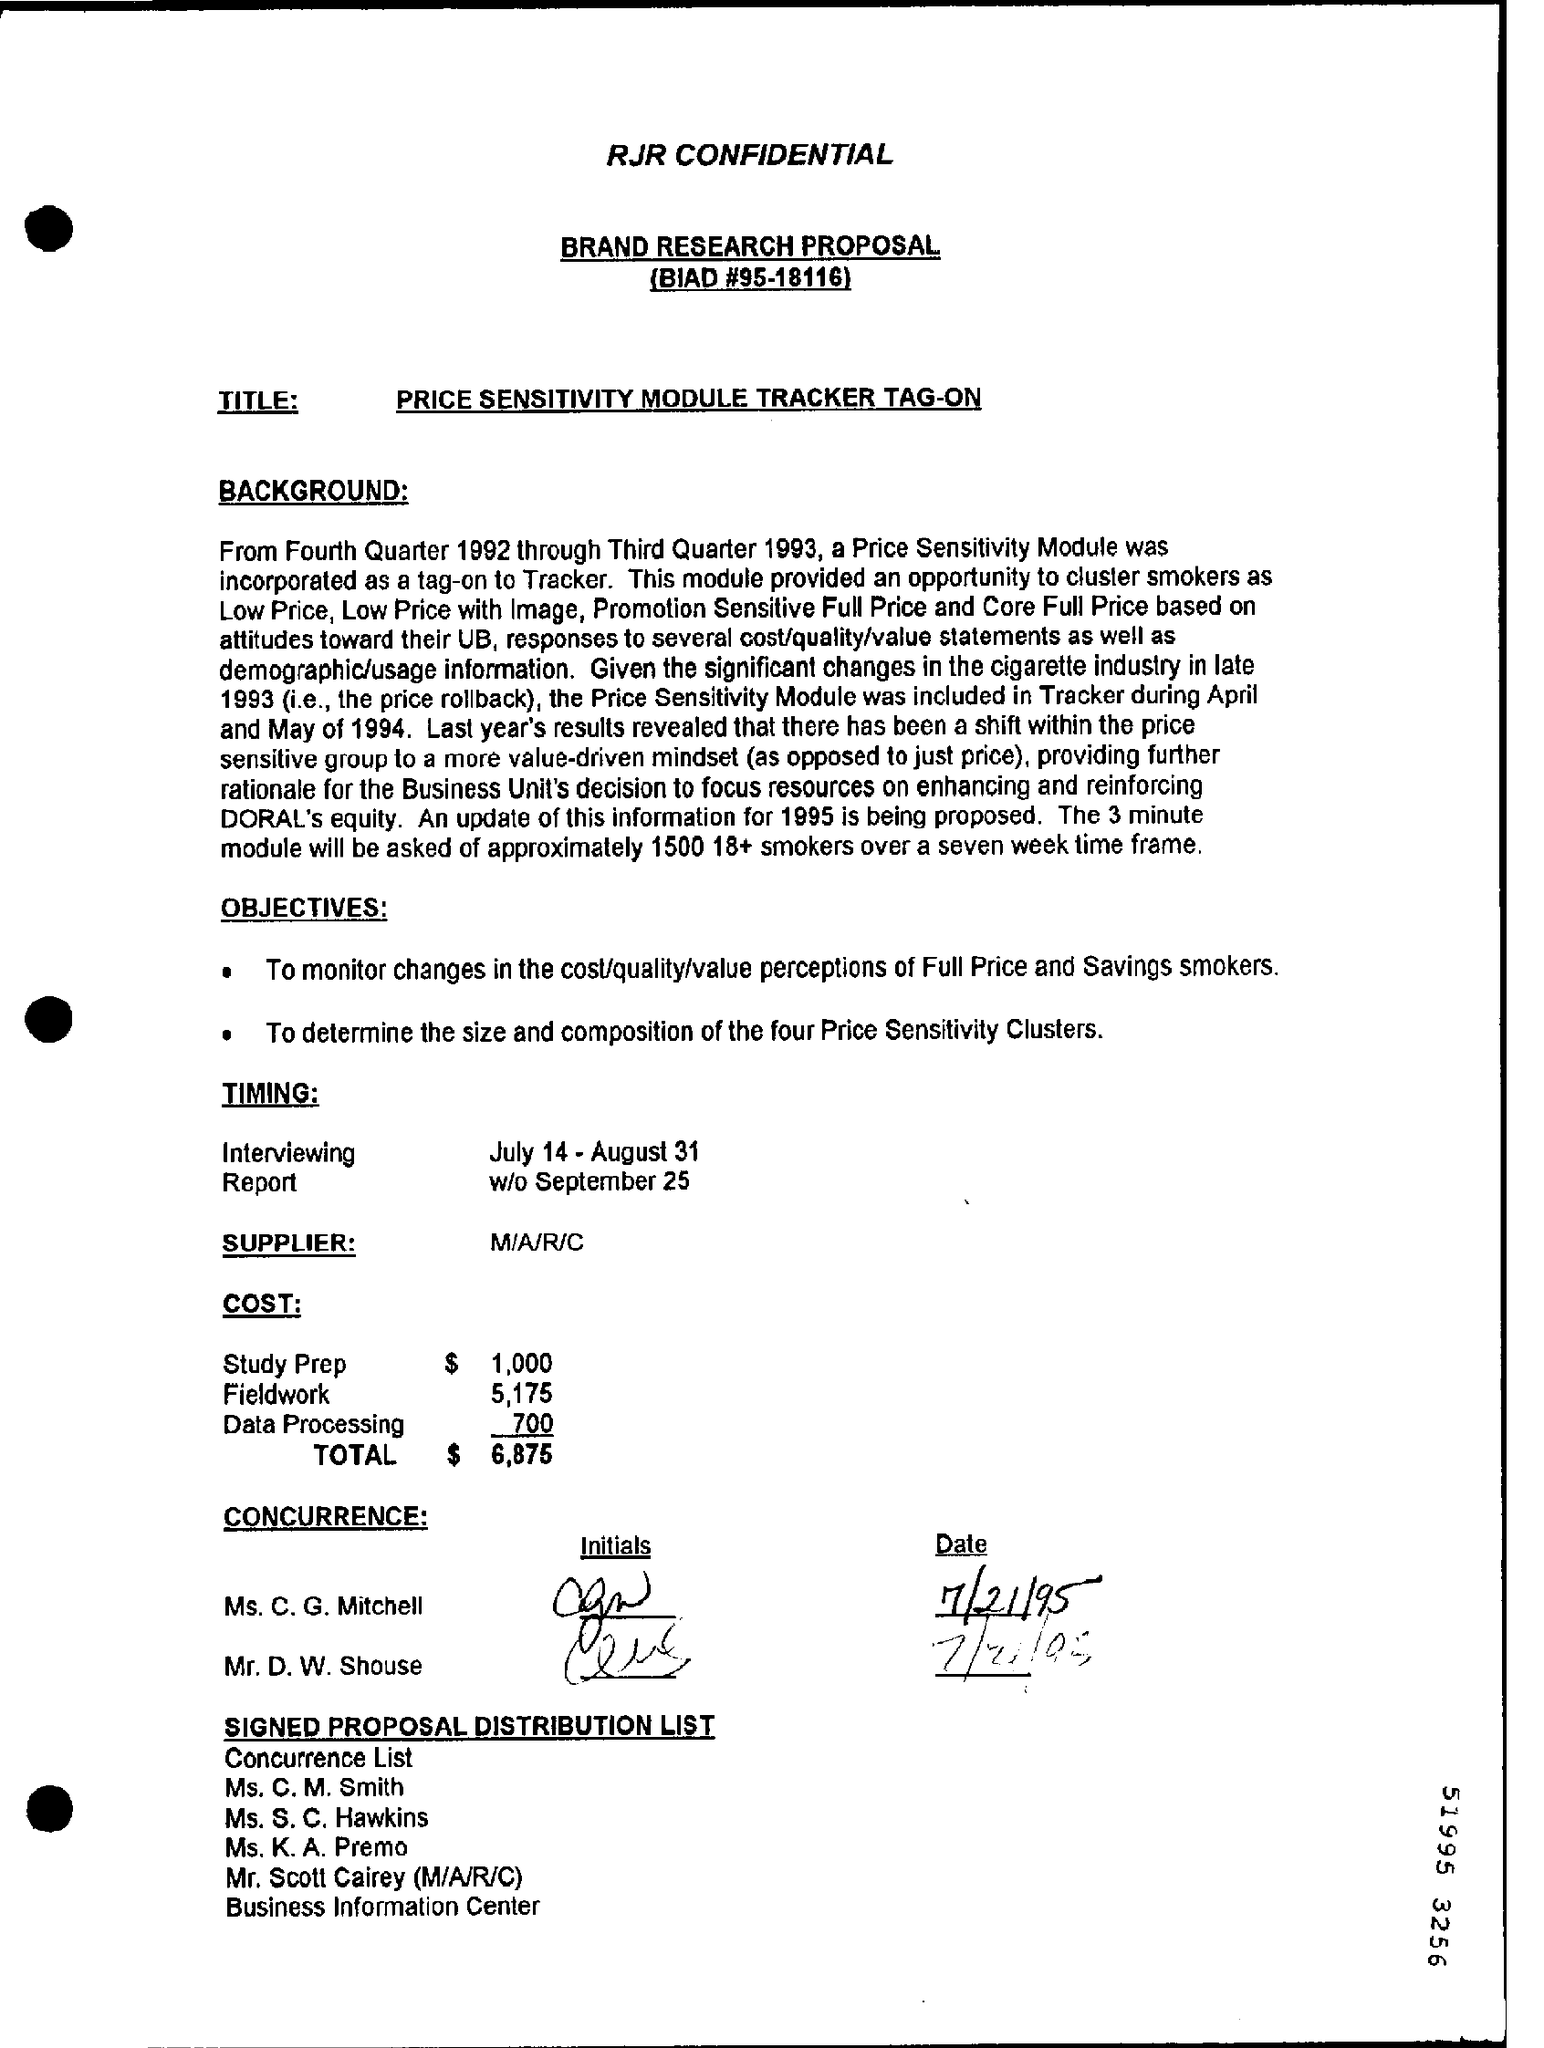What is the BIAD #?
Offer a very short reply. 95-18116. What is the total cost mentioned?
Make the answer very short. $ 6,875. 